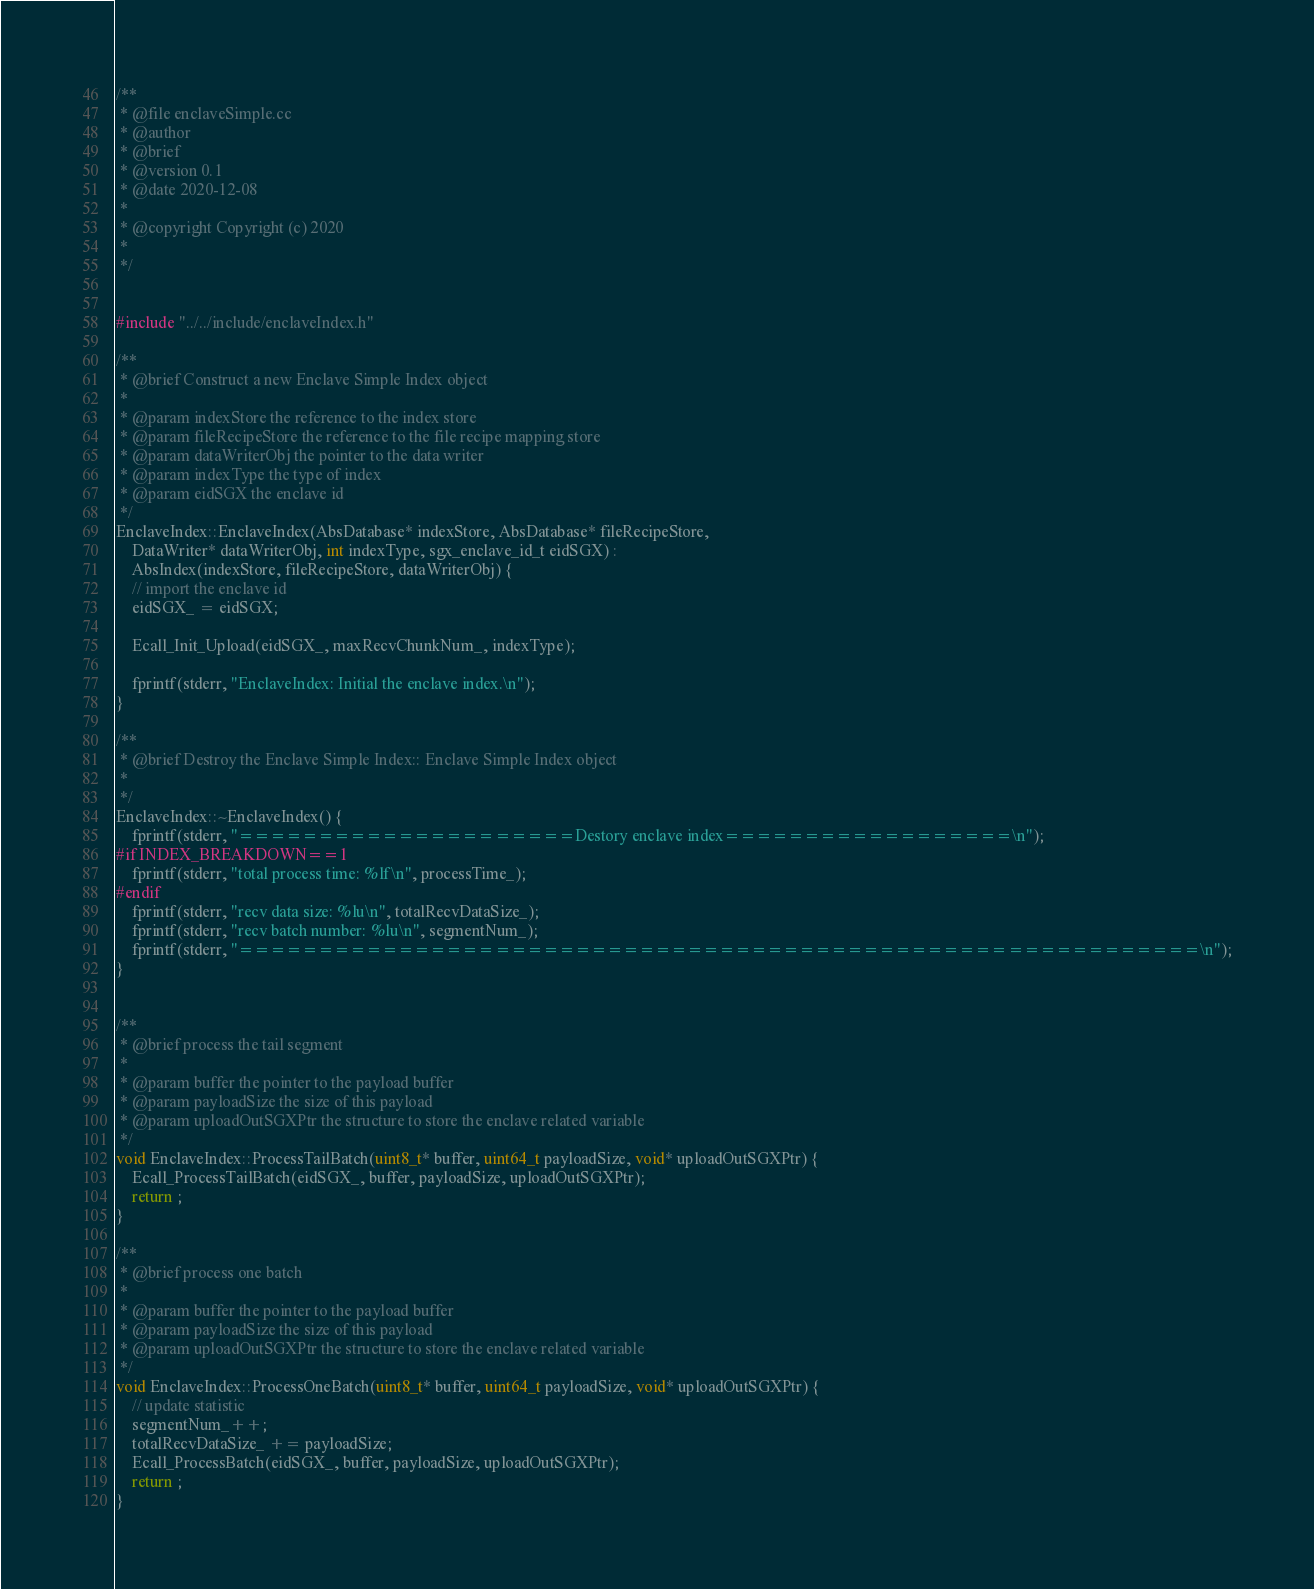<code> <loc_0><loc_0><loc_500><loc_500><_C++_>/**
 * @file enclaveSimple.cc
 * @author 
 * @brief 
 * @version 0.1
 * @date 2020-12-08
 * 
 * @copyright Copyright (c) 2020
 * 
 */


#include "../../include/enclaveIndex.h"

/**
 * @brief Construct a new Enclave Simple Index object
 * 
 * @param indexStore the reference to the index store
 * @param fileRecipeStore the reference to the file recipe mapping store
 * @param dataWriterObj the pointer to the data writer
 * @param indexType the type of index
 * @param eidSGX the enclave id
 */
EnclaveIndex::EnclaveIndex(AbsDatabase* indexStore, AbsDatabase* fileRecipeStore,
    DataWriter* dataWriterObj, int indexType, sgx_enclave_id_t eidSGX) : 
    AbsIndex(indexStore, fileRecipeStore, dataWriterObj) {
    // import the enclave id
    eidSGX_ = eidSGX;

    Ecall_Init_Upload(eidSGX_, maxRecvChunkNum_, indexType);

    fprintf(stderr, "EnclaveIndex: Initial the enclave index.\n");
}

/**
 * @brief Destroy the Enclave Simple Index:: Enclave Simple Index object
 * 
 */
EnclaveIndex::~EnclaveIndex() {
    fprintf(stderr, "=====================Destory enclave index==================\n");
#if INDEX_BREAKDOWN==1
    fprintf(stderr, "total process time: %lf\n", processTime_);
#endif
    fprintf(stderr, "recv data size: %lu\n", totalRecvDataSize_);
    fprintf(stderr, "recv batch number: %lu\n", segmentNum_);
    fprintf(stderr, "============================================================\n");
}


/**
 * @brief process the tail segment
 * 
 * @param buffer the pointer to the payload buffer
 * @param payloadSize the size of this payload
 * @param uploadOutSGXPtr the structure to store the enclave related variable
 */
void EnclaveIndex::ProcessTailBatch(uint8_t* buffer, uint64_t payloadSize, void* uploadOutSGXPtr) {
    Ecall_ProcessTailBatch(eidSGX_, buffer, payloadSize, uploadOutSGXPtr);
    return ;
}

/**
 * @brief process one batch 
 * 
 * @param buffer the pointer to the payload buffer
 * @param payloadSize the size of this payload
 * @param uploadOutSGXPtr the structure to store the enclave related variable
 */
void EnclaveIndex::ProcessOneBatch(uint8_t* buffer, uint64_t payloadSize, void* uploadOutSGXPtr) {
    // update statistic 
    segmentNum_++;
    totalRecvDataSize_ += payloadSize;
    Ecall_ProcessBatch(eidSGX_, buffer, payloadSize, uploadOutSGXPtr);
    return ;
}</code> 